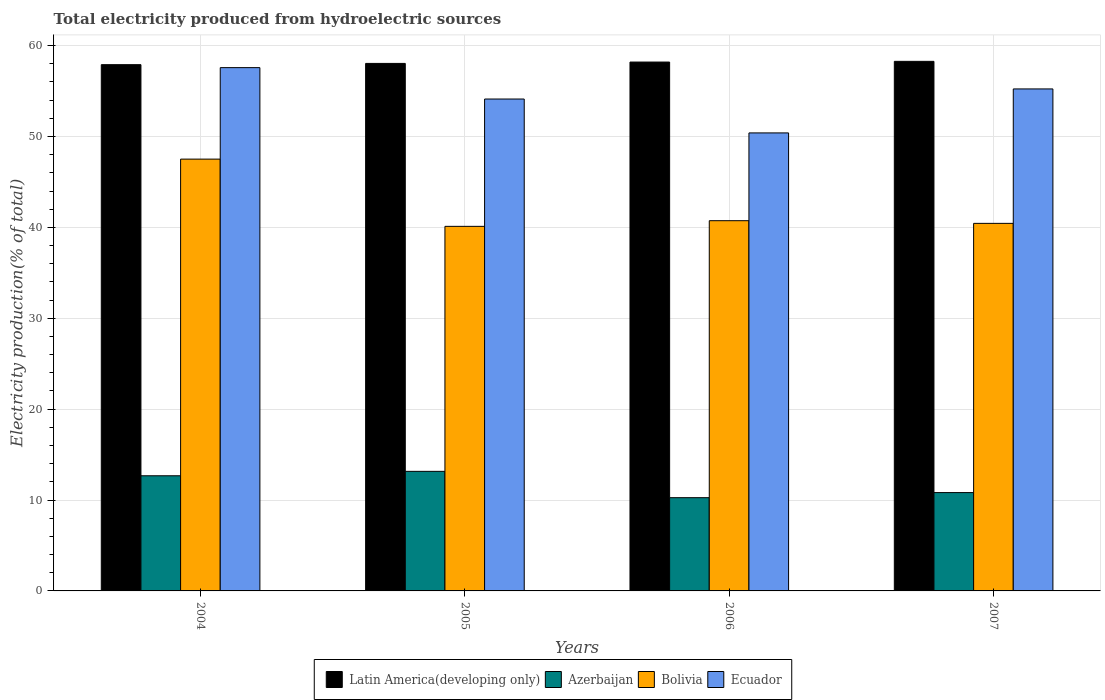How many groups of bars are there?
Provide a short and direct response. 4. Are the number of bars per tick equal to the number of legend labels?
Offer a very short reply. Yes. Are the number of bars on each tick of the X-axis equal?
Keep it short and to the point. Yes. How many bars are there on the 4th tick from the left?
Your answer should be compact. 4. How many bars are there on the 2nd tick from the right?
Your answer should be compact. 4. In how many cases, is the number of bars for a given year not equal to the number of legend labels?
Offer a terse response. 0. What is the total electricity produced in Azerbaijan in 2006?
Provide a short and direct response. 10.26. Across all years, what is the maximum total electricity produced in Ecuador?
Give a very brief answer. 57.58. Across all years, what is the minimum total electricity produced in Bolivia?
Ensure brevity in your answer.  40.11. In which year was the total electricity produced in Latin America(developing only) minimum?
Your answer should be very brief. 2004. What is the total total electricity produced in Azerbaijan in the graph?
Your answer should be compact. 46.91. What is the difference between the total electricity produced in Bolivia in 2004 and that in 2006?
Make the answer very short. 6.78. What is the difference between the total electricity produced in Azerbaijan in 2005 and the total electricity produced in Bolivia in 2004?
Provide a short and direct response. -34.36. What is the average total electricity produced in Latin America(developing only) per year?
Your answer should be compact. 58.1. In the year 2004, what is the difference between the total electricity produced in Bolivia and total electricity produced in Ecuador?
Your answer should be compact. -10.07. In how many years, is the total electricity produced in Ecuador greater than 52 %?
Your answer should be very brief. 3. What is the ratio of the total electricity produced in Azerbaijan in 2006 to that in 2007?
Give a very brief answer. 0.95. Is the total electricity produced in Latin America(developing only) in 2005 less than that in 2007?
Give a very brief answer. Yes. What is the difference between the highest and the second highest total electricity produced in Azerbaijan?
Keep it short and to the point. 0.49. What is the difference between the highest and the lowest total electricity produced in Bolivia?
Keep it short and to the point. 7.4. In how many years, is the total electricity produced in Ecuador greater than the average total electricity produced in Ecuador taken over all years?
Offer a terse response. 2. Is the sum of the total electricity produced in Azerbaijan in 2005 and 2006 greater than the maximum total electricity produced in Latin America(developing only) across all years?
Your answer should be compact. No. Is it the case that in every year, the sum of the total electricity produced in Latin America(developing only) and total electricity produced in Bolivia is greater than the sum of total electricity produced in Ecuador and total electricity produced in Azerbaijan?
Give a very brief answer. No. What does the 4th bar from the left in 2006 represents?
Your answer should be very brief. Ecuador. What does the 3rd bar from the right in 2006 represents?
Offer a terse response. Azerbaijan. Is it the case that in every year, the sum of the total electricity produced in Azerbaijan and total electricity produced in Bolivia is greater than the total electricity produced in Ecuador?
Your response must be concise. No. How many years are there in the graph?
Your answer should be very brief. 4. Are the values on the major ticks of Y-axis written in scientific E-notation?
Your answer should be compact. No. Where does the legend appear in the graph?
Ensure brevity in your answer.  Bottom center. How many legend labels are there?
Provide a short and direct response. 4. What is the title of the graph?
Offer a very short reply. Total electricity produced from hydroelectric sources. Does "Belgium" appear as one of the legend labels in the graph?
Your response must be concise. No. What is the label or title of the X-axis?
Provide a succinct answer. Years. What is the label or title of the Y-axis?
Keep it short and to the point. Electricity production(% of total). What is the Electricity production(% of total) in Latin America(developing only) in 2004?
Offer a very short reply. 57.9. What is the Electricity production(% of total) of Azerbaijan in 2004?
Give a very brief answer. 12.67. What is the Electricity production(% of total) in Bolivia in 2004?
Keep it short and to the point. 47.51. What is the Electricity production(% of total) in Ecuador in 2004?
Offer a terse response. 57.58. What is the Electricity production(% of total) in Latin America(developing only) in 2005?
Offer a terse response. 58.04. What is the Electricity production(% of total) of Azerbaijan in 2005?
Your answer should be compact. 13.16. What is the Electricity production(% of total) in Bolivia in 2005?
Provide a succinct answer. 40.11. What is the Electricity production(% of total) of Ecuador in 2005?
Offer a very short reply. 54.12. What is the Electricity production(% of total) in Latin America(developing only) in 2006?
Keep it short and to the point. 58.19. What is the Electricity production(% of total) in Azerbaijan in 2006?
Offer a very short reply. 10.26. What is the Electricity production(% of total) in Bolivia in 2006?
Your response must be concise. 40.74. What is the Electricity production(% of total) in Ecuador in 2006?
Provide a short and direct response. 50.4. What is the Electricity production(% of total) of Latin America(developing only) in 2007?
Your response must be concise. 58.27. What is the Electricity production(% of total) of Azerbaijan in 2007?
Your answer should be very brief. 10.82. What is the Electricity production(% of total) of Bolivia in 2007?
Offer a terse response. 40.44. What is the Electricity production(% of total) of Ecuador in 2007?
Make the answer very short. 55.24. Across all years, what is the maximum Electricity production(% of total) of Latin America(developing only)?
Provide a short and direct response. 58.27. Across all years, what is the maximum Electricity production(% of total) in Azerbaijan?
Your answer should be very brief. 13.16. Across all years, what is the maximum Electricity production(% of total) in Bolivia?
Provide a succinct answer. 47.51. Across all years, what is the maximum Electricity production(% of total) of Ecuador?
Make the answer very short. 57.58. Across all years, what is the minimum Electricity production(% of total) of Latin America(developing only)?
Keep it short and to the point. 57.9. Across all years, what is the minimum Electricity production(% of total) of Azerbaijan?
Provide a short and direct response. 10.26. Across all years, what is the minimum Electricity production(% of total) in Bolivia?
Your answer should be very brief. 40.11. Across all years, what is the minimum Electricity production(% of total) of Ecuador?
Make the answer very short. 50.4. What is the total Electricity production(% of total) in Latin America(developing only) in the graph?
Provide a succinct answer. 232.41. What is the total Electricity production(% of total) of Azerbaijan in the graph?
Offer a terse response. 46.91. What is the total Electricity production(% of total) of Bolivia in the graph?
Offer a very short reply. 168.81. What is the total Electricity production(% of total) in Ecuador in the graph?
Your answer should be very brief. 217.33. What is the difference between the Electricity production(% of total) of Latin America(developing only) in 2004 and that in 2005?
Your answer should be very brief. -0.14. What is the difference between the Electricity production(% of total) of Azerbaijan in 2004 and that in 2005?
Provide a succinct answer. -0.49. What is the difference between the Electricity production(% of total) in Bolivia in 2004 and that in 2005?
Provide a succinct answer. 7.4. What is the difference between the Electricity production(% of total) in Ecuador in 2004 and that in 2005?
Your answer should be very brief. 3.45. What is the difference between the Electricity production(% of total) of Latin America(developing only) in 2004 and that in 2006?
Provide a succinct answer. -0.29. What is the difference between the Electricity production(% of total) in Azerbaijan in 2004 and that in 2006?
Keep it short and to the point. 2.41. What is the difference between the Electricity production(% of total) in Bolivia in 2004 and that in 2006?
Your answer should be compact. 6.78. What is the difference between the Electricity production(% of total) in Ecuador in 2004 and that in 2006?
Your answer should be very brief. 7.18. What is the difference between the Electricity production(% of total) of Latin America(developing only) in 2004 and that in 2007?
Provide a succinct answer. -0.36. What is the difference between the Electricity production(% of total) of Azerbaijan in 2004 and that in 2007?
Provide a succinct answer. 1.85. What is the difference between the Electricity production(% of total) in Bolivia in 2004 and that in 2007?
Keep it short and to the point. 7.07. What is the difference between the Electricity production(% of total) in Ecuador in 2004 and that in 2007?
Provide a succinct answer. 2.34. What is the difference between the Electricity production(% of total) in Latin America(developing only) in 2005 and that in 2006?
Your answer should be very brief. -0.15. What is the difference between the Electricity production(% of total) of Azerbaijan in 2005 and that in 2006?
Offer a very short reply. 2.9. What is the difference between the Electricity production(% of total) in Bolivia in 2005 and that in 2006?
Provide a short and direct response. -0.62. What is the difference between the Electricity production(% of total) of Ecuador in 2005 and that in 2006?
Make the answer very short. 3.73. What is the difference between the Electricity production(% of total) in Latin America(developing only) in 2005 and that in 2007?
Ensure brevity in your answer.  -0.23. What is the difference between the Electricity production(% of total) in Azerbaijan in 2005 and that in 2007?
Provide a succinct answer. 2.34. What is the difference between the Electricity production(% of total) in Bolivia in 2005 and that in 2007?
Your answer should be compact. -0.33. What is the difference between the Electricity production(% of total) in Ecuador in 2005 and that in 2007?
Give a very brief answer. -1.11. What is the difference between the Electricity production(% of total) in Latin America(developing only) in 2006 and that in 2007?
Your response must be concise. -0.08. What is the difference between the Electricity production(% of total) in Azerbaijan in 2006 and that in 2007?
Your response must be concise. -0.56. What is the difference between the Electricity production(% of total) of Bolivia in 2006 and that in 2007?
Your answer should be compact. 0.29. What is the difference between the Electricity production(% of total) of Ecuador in 2006 and that in 2007?
Offer a very short reply. -4.84. What is the difference between the Electricity production(% of total) of Latin America(developing only) in 2004 and the Electricity production(% of total) of Azerbaijan in 2005?
Provide a succinct answer. 44.75. What is the difference between the Electricity production(% of total) in Latin America(developing only) in 2004 and the Electricity production(% of total) in Bolivia in 2005?
Ensure brevity in your answer.  17.79. What is the difference between the Electricity production(% of total) of Latin America(developing only) in 2004 and the Electricity production(% of total) of Ecuador in 2005?
Your answer should be compact. 3.78. What is the difference between the Electricity production(% of total) in Azerbaijan in 2004 and the Electricity production(% of total) in Bolivia in 2005?
Provide a short and direct response. -27.44. What is the difference between the Electricity production(% of total) in Azerbaijan in 2004 and the Electricity production(% of total) in Ecuador in 2005?
Give a very brief answer. -41.45. What is the difference between the Electricity production(% of total) of Bolivia in 2004 and the Electricity production(% of total) of Ecuador in 2005?
Provide a short and direct response. -6.61. What is the difference between the Electricity production(% of total) of Latin America(developing only) in 2004 and the Electricity production(% of total) of Azerbaijan in 2006?
Ensure brevity in your answer.  47.64. What is the difference between the Electricity production(% of total) in Latin America(developing only) in 2004 and the Electricity production(% of total) in Bolivia in 2006?
Offer a very short reply. 17.17. What is the difference between the Electricity production(% of total) in Latin America(developing only) in 2004 and the Electricity production(% of total) in Ecuador in 2006?
Provide a short and direct response. 7.51. What is the difference between the Electricity production(% of total) of Azerbaijan in 2004 and the Electricity production(% of total) of Bolivia in 2006?
Provide a succinct answer. -28.07. What is the difference between the Electricity production(% of total) of Azerbaijan in 2004 and the Electricity production(% of total) of Ecuador in 2006?
Give a very brief answer. -37.73. What is the difference between the Electricity production(% of total) in Bolivia in 2004 and the Electricity production(% of total) in Ecuador in 2006?
Keep it short and to the point. -2.88. What is the difference between the Electricity production(% of total) of Latin America(developing only) in 2004 and the Electricity production(% of total) of Azerbaijan in 2007?
Offer a very short reply. 47.08. What is the difference between the Electricity production(% of total) in Latin America(developing only) in 2004 and the Electricity production(% of total) in Bolivia in 2007?
Give a very brief answer. 17.46. What is the difference between the Electricity production(% of total) in Latin America(developing only) in 2004 and the Electricity production(% of total) in Ecuador in 2007?
Provide a short and direct response. 2.67. What is the difference between the Electricity production(% of total) of Azerbaijan in 2004 and the Electricity production(% of total) of Bolivia in 2007?
Provide a succinct answer. -27.77. What is the difference between the Electricity production(% of total) in Azerbaijan in 2004 and the Electricity production(% of total) in Ecuador in 2007?
Offer a terse response. -42.56. What is the difference between the Electricity production(% of total) in Bolivia in 2004 and the Electricity production(% of total) in Ecuador in 2007?
Your answer should be compact. -7.72. What is the difference between the Electricity production(% of total) of Latin America(developing only) in 2005 and the Electricity production(% of total) of Azerbaijan in 2006?
Make the answer very short. 47.78. What is the difference between the Electricity production(% of total) of Latin America(developing only) in 2005 and the Electricity production(% of total) of Bolivia in 2006?
Your answer should be compact. 17.31. What is the difference between the Electricity production(% of total) in Latin America(developing only) in 2005 and the Electricity production(% of total) in Ecuador in 2006?
Ensure brevity in your answer.  7.65. What is the difference between the Electricity production(% of total) of Azerbaijan in 2005 and the Electricity production(% of total) of Bolivia in 2006?
Keep it short and to the point. -27.58. What is the difference between the Electricity production(% of total) of Azerbaijan in 2005 and the Electricity production(% of total) of Ecuador in 2006?
Your answer should be compact. -37.24. What is the difference between the Electricity production(% of total) of Bolivia in 2005 and the Electricity production(% of total) of Ecuador in 2006?
Your answer should be very brief. -10.28. What is the difference between the Electricity production(% of total) in Latin America(developing only) in 2005 and the Electricity production(% of total) in Azerbaijan in 2007?
Provide a succinct answer. 47.22. What is the difference between the Electricity production(% of total) in Latin America(developing only) in 2005 and the Electricity production(% of total) in Bolivia in 2007?
Your answer should be compact. 17.6. What is the difference between the Electricity production(% of total) of Latin America(developing only) in 2005 and the Electricity production(% of total) of Ecuador in 2007?
Your answer should be very brief. 2.81. What is the difference between the Electricity production(% of total) in Azerbaijan in 2005 and the Electricity production(% of total) in Bolivia in 2007?
Offer a terse response. -27.29. What is the difference between the Electricity production(% of total) in Azerbaijan in 2005 and the Electricity production(% of total) in Ecuador in 2007?
Give a very brief answer. -42.08. What is the difference between the Electricity production(% of total) in Bolivia in 2005 and the Electricity production(% of total) in Ecuador in 2007?
Provide a short and direct response. -15.12. What is the difference between the Electricity production(% of total) in Latin America(developing only) in 2006 and the Electricity production(% of total) in Azerbaijan in 2007?
Offer a terse response. 47.37. What is the difference between the Electricity production(% of total) of Latin America(developing only) in 2006 and the Electricity production(% of total) of Bolivia in 2007?
Keep it short and to the point. 17.75. What is the difference between the Electricity production(% of total) in Latin America(developing only) in 2006 and the Electricity production(% of total) in Ecuador in 2007?
Provide a succinct answer. 2.96. What is the difference between the Electricity production(% of total) of Azerbaijan in 2006 and the Electricity production(% of total) of Bolivia in 2007?
Your answer should be compact. -30.18. What is the difference between the Electricity production(% of total) of Azerbaijan in 2006 and the Electricity production(% of total) of Ecuador in 2007?
Offer a terse response. -44.98. What is the difference between the Electricity production(% of total) of Bolivia in 2006 and the Electricity production(% of total) of Ecuador in 2007?
Keep it short and to the point. -14.5. What is the average Electricity production(% of total) of Latin America(developing only) per year?
Your answer should be compact. 58.1. What is the average Electricity production(% of total) in Azerbaijan per year?
Your response must be concise. 11.73. What is the average Electricity production(% of total) of Bolivia per year?
Your response must be concise. 42.2. What is the average Electricity production(% of total) of Ecuador per year?
Ensure brevity in your answer.  54.33. In the year 2004, what is the difference between the Electricity production(% of total) of Latin America(developing only) and Electricity production(% of total) of Azerbaijan?
Your answer should be compact. 45.23. In the year 2004, what is the difference between the Electricity production(% of total) of Latin America(developing only) and Electricity production(% of total) of Bolivia?
Offer a terse response. 10.39. In the year 2004, what is the difference between the Electricity production(% of total) in Latin America(developing only) and Electricity production(% of total) in Ecuador?
Keep it short and to the point. 0.33. In the year 2004, what is the difference between the Electricity production(% of total) in Azerbaijan and Electricity production(% of total) in Bolivia?
Offer a terse response. -34.84. In the year 2004, what is the difference between the Electricity production(% of total) of Azerbaijan and Electricity production(% of total) of Ecuador?
Your response must be concise. -44.91. In the year 2004, what is the difference between the Electricity production(% of total) of Bolivia and Electricity production(% of total) of Ecuador?
Provide a succinct answer. -10.07. In the year 2005, what is the difference between the Electricity production(% of total) of Latin America(developing only) and Electricity production(% of total) of Azerbaijan?
Ensure brevity in your answer.  44.89. In the year 2005, what is the difference between the Electricity production(% of total) of Latin America(developing only) and Electricity production(% of total) of Bolivia?
Your response must be concise. 17.93. In the year 2005, what is the difference between the Electricity production(% of total) of Latin America(developing only) and Electricity production(% of total) of Ecuador?
Give a very brief answer. 3.92. In the year 2005, what is the difference between the Electricity production(% of total) of Azerbaijan and Electricity production(% of total) of Bolivia?
Keep it short and to the point. -26.96. In the year 2005, what is the difference between the Electricity production(% of total) in Azerbaijan and Electricity production(% of total) in Ecuador?
Ensure brevity in your answer.  -40.97. In the year 2005, what is the difference between the Electricity production(% of total) in Bolivia and Electricity production(% of total) in Ecuador?
Your response must be concise. -14.01. In the year 2006, what is the difference between the Electricity production(% of total) of Latin America(developing only) and Electricity production(% of total) of Azerbaijan?
Offer a terse response. 47.93. In the year 2006, what is the difference between the Electricity production(% of total) of Latin America(developing only) and Electricity production(% of total) of Bolivia?
Offer a very short reply. 17.46. In the year 2006, what is the difference between the Electricity production(% of total) of Latin America(developing only) and Electricity production(% of total) of Ecuador?
Your answer should be compact. 7.8. In the year 2006, what is the difference between the Electricity production(% of total) of Azerbaijan and Electricity production(% of total) of Bolivia?
Provide a succinct answer. -30.48. In the year 2006, what is the difference between the Electricity production(% of total) in Azerbaijan and Electricity production(% of total) in Ecuador?
Your answer should be very brief. -40.14. In the year 2006, what is the difference between the Electricity production(% of total) in Bolivia and Electricity production(% of total) in Ecuador?
Ensure brevity in your answer.  -9.66. In the year 2007, what is the difference between the Electricity production(% of total) of Latin America(developing only) and Electricity production(% of total) of Azerbaijan?
Offer a very short reply. 47.45. In the year 2007, what is the difference between the Electricity production(% of total) of Latin America(developing only) and Electricity production(% of total) of Bolivia?
Offer a very short reply. 17.83. In the year 2007, what is the difference between the Electricity production(% of total) in Latin America(developing only) and Electricity production(% of total) in Ecuador?
Keep it short and to the point. 3.03. In the year 2007, what is the difference between the Electricity production(% of total) of Azerbaijan and Electricity production(% of total) of Bolivia?
Ensure brevity in your answer.  -29.62. In the year 2007, what is the difference between the Electricity production(% of total) of Azerbaijan and Electricity production(% of total) of Ecuador?
Give a very brief answer. -44.41. In the year 2007, what is the difference between the Electricity production(% of total) in Bolivia and Electricity production(% of total) in Ecuador?
Provide a short and direct response. -14.79. What is the ratio of the Electricity production(% of total) in Azerbaijan in 2004 to that in 2005?
Make the answer very short. 0.96. What is the ratio of the Electricity production(% of total) of Bolivia in 2004 to that in 2005?
Offer a very short reply. 1.18. What is the ratio of the Electricity production(% of total) in Ecuador in 2004 to that in 2005?
Offer a terse response. 1.06. What is the ratio of the Electricity production(% of total) in Azerbaijan in 2004 to that in 2006?
Make the answer very short. 1.24. What is the ratio of the Electricity production(% of total) of Bolivia in 2004 to that in 2006?
Give a very brief answer. 1.17. What is the ratio of the Electricity production(% of total) in Ecuador in 2004 to that in 2006?
Offer a very short reply. 1.14. What is the ratio of the Electricity production(% of total) of Latin America(developing only) in 2004 to that in 2007?
Ensure brevity in your answer.  0.99. What is the ratio of the Electricity production(% of total) in Azerbaijan in 2004 to that in 2007?
Your answer should be compact. 1.17. What is the ratio of the Electricity production(% of total) of Bolivia in 2004 to that in 2007?
Provide a succinct answer. 1.17. What is the ratio of the Electricity production(% of total) in Ecuador in 2004 to that in 2007?
Keep it short and to the point. 1.04. What is the ratio of the Electricity production(% of total) of Azerbaijan in 2005 to that in 2006?
Your answer should be very brief. 1.28. What is the ratio of the Electricity production(% of total) of Bolivia in 2005 to that in 2006?
Your answer should be very brief. 0.98. What is the ratio of the Electricity production(% of total) in Ecuador in 2005 to that in 2006?
Your answer should be very brief. 1.07. What is the ratio of the Electricity production(% of total) in Latin America(developing only) in 2005 to that in 2007?
Make the answer very short. 1. What is the ratio of the Electricity production(% of total) of Azerbaijan in 2005 to that in 2007?
Offer a very short reply. 1.22. What is the ratio of the Electricity production(% of total) in Ecuador in 2005 to that in 2007?
Provide a short and direct response. 0.98. What is the ratio of the Electricity production(% of total) of Latin America(developing only) in 2006 to that in 2007?
Your answer should be compact. 1. What is the ratio of the Electricity production(% of total) of Azerbaijan in 2006 to that in 2007?
Your response must be concise. 0.95. What is the ratio of the Electricity production(% of total) of Bolivia in 2006 to that in 2007?
Ensure brevity in your answer.  1.01. What is the ratio of the Electricity production(% of total) of Ecuador in 2006 to that in 2007?
Provide a succinct answer. 0.91. What is the difference between the highest and the second highest Electricity production(% of total) in Latin America(developing only)?
Give a very brief answer. 0.08. What is the difference between the highest and the second highest Electricity production(% of total) in Azerbaijan?
Your response must be concise. 0.49. What is the difference between the highest and the second highest Electricity production(% of total) in Bolivia?
Your answer should be very brief. 6.78. What is the difference between the highest and the second highest Electricity production(% of total) in Ecuador?
Provide a short and direct response. 2.34. What is the difference between the highest and the lowest Electricity production(% of total) in Latin America(developing only)?
Your answer should be very brief. 0.36. What is the difference between the highest and the lowest Electricity production(% of total) of Azerbaijan?
Offer a terse response. 2.9. What is the difference between the highest and the lowest Electricity production(% of total) of Bolivia?
Offer a very short reply. 7.4. What is the difference between the highest and the lowest Electricity production(% of total) in Ecuador?
Your answer should be compact. 7.18. 